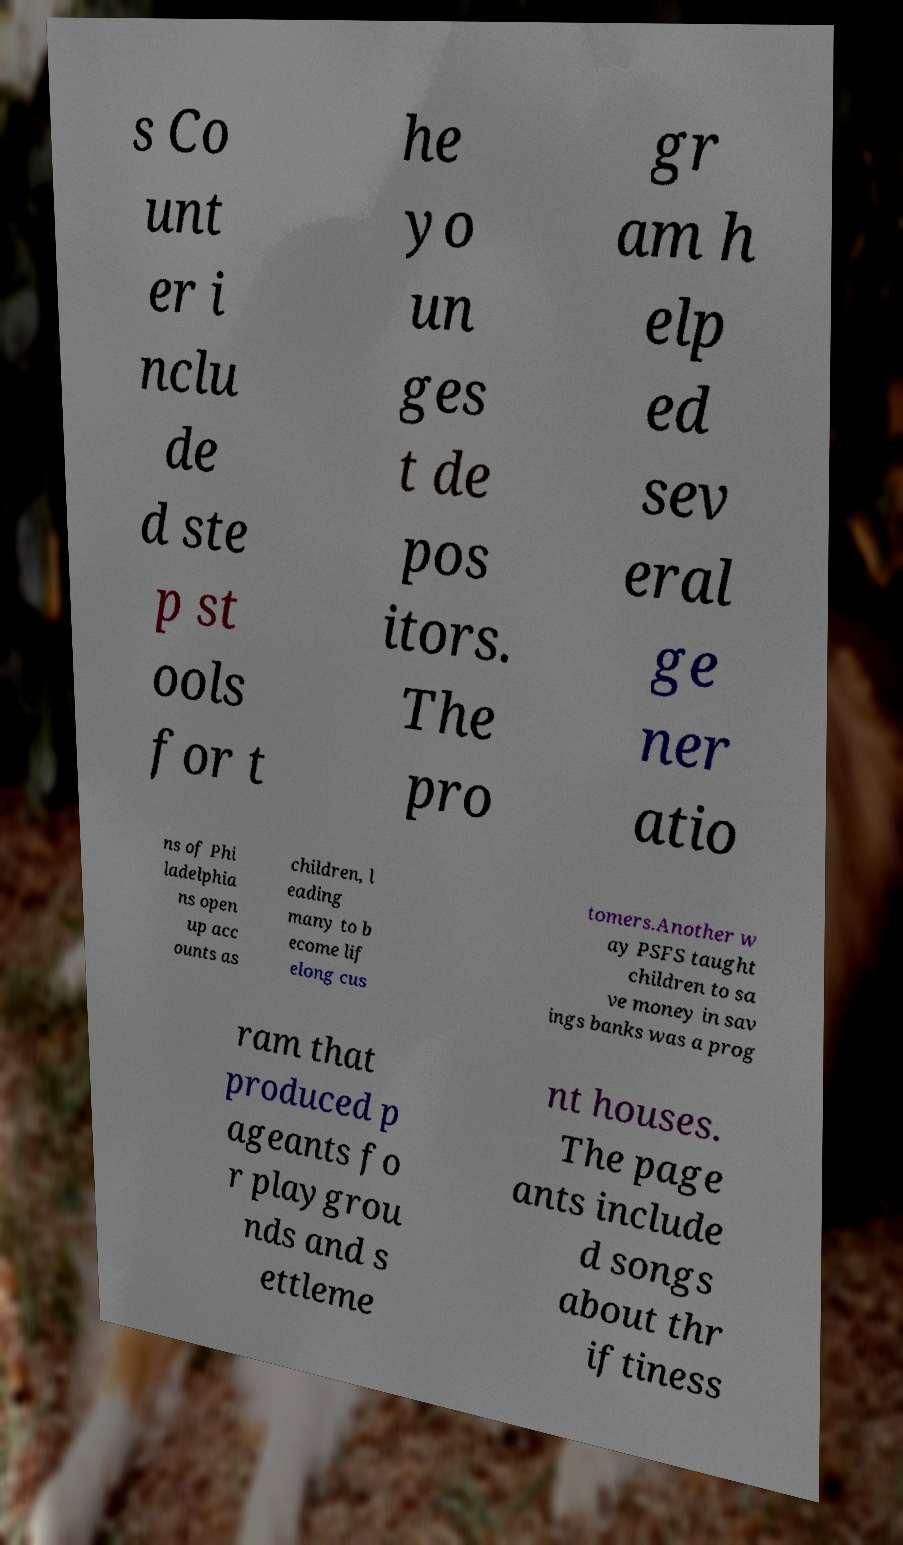Can you accurately transcribe the text from the provided image for me? s Co unt er i nclu de d ste p st ools for t he yo un ges t de pos itors. The pro gr am h elp ed sev eral ge ner atio ns of Phi ladelphia ns open up acc ounts as children, l eading many to b ecome lif elong cus tomers.Another w ay PSFS taught children to sa ve money in sav ings banks was a prog ram that produced p ageants fo r playgrou nds and s ettleme nt houses. The page ants include d songs about thr iftiness 